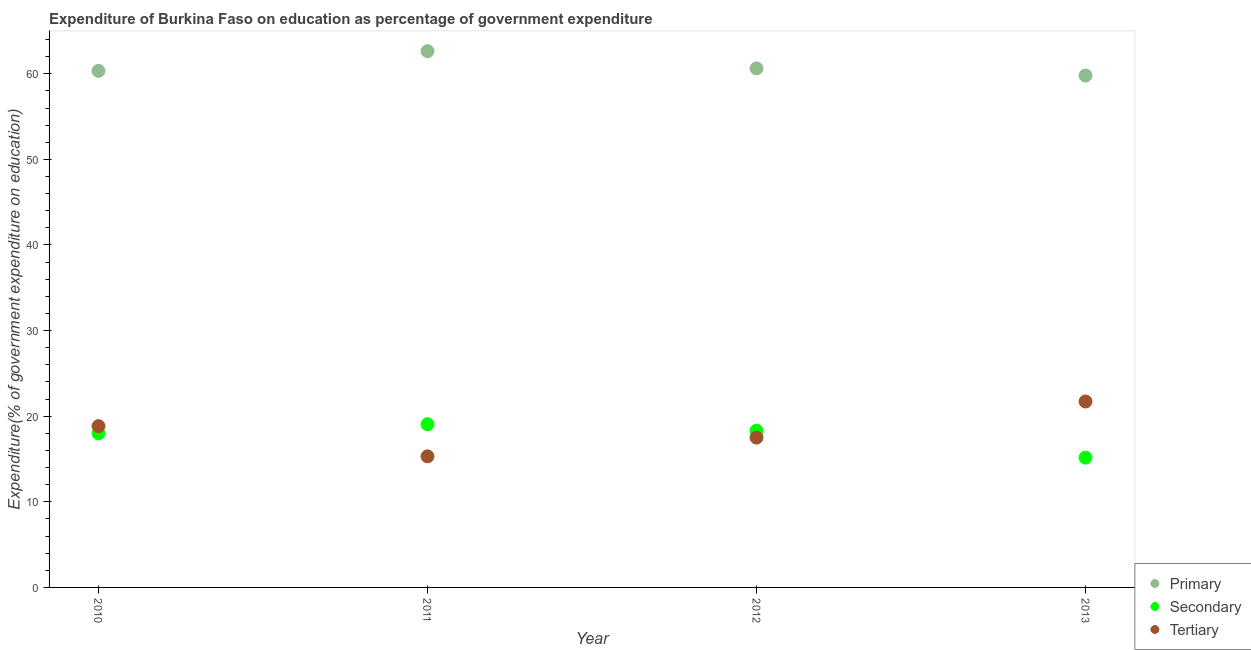Is the number of dotlines equal to the number of legend labels?
Your answer should be compact. Yes. What is the expenditure on secondary education in 2010?
Offer a very short reply. 18. Across all years, what is the maximum expenditure on secondary education?
Offer a very short reply. 19.06. Across all years, what is the minimum expenditure on secondary education?
Your answer should be compact. 15.16. In which year was the expenditure on tertiary education maximum?
Offer a terse response. 2013. In which year was the expenditure on primary education minimum?
Offer a terse response. 2013. What is the total expenditure on tertiary education in the graph?
Give a very brief answer. 73.37. What is the difference between the expenditure on primary education in 2010 and that in 2013?
Offer a terse response. 0.55. What is the difference between the expenditure on tertiary education in 2011 and the expenditure on secondary education in 2013?
Provide a succinct answer. 0.15. What is the average expenditure on secondary education per year?
Provide a succinct answer. 17.63. In the year 2013, what is the difference between the expenditure on primary education and expenditure on secondary education?
Your answer should be very brief. 44.63. In how many years, is the expenditure on secondary education greater than 50 %?
Provide a short and direct response. 0. What is the ratio of the expenditure on secondary education in 2010 to that in 2013?
Your answer should be compact. 1.19. What is the difference between the highest and the second highest expenditure on primary education?
Provide a short and direct response. 2.01. What is the difference between the highest and the lowest expenditure on secondary education?
Make the answer very short. 3.9. Is it the case that in every year, the sum of the expenditure on primary education and expenditure on secondary education is greater than the expenditure on tertiary education?
Make the answer very short. Yes. Does the expenditure on primary education monotonically increase over the years?
Your response must be concise. No. What is the difference between two consecutive major ticks on the Y-axis?
Offer a terse response. 10. Does the graph contain any zero values?
Your answer should be very brief. No. Where does the legend appear in the graph?
Provide a succinct answer. Bottom right. How many legend labels are there?
Keep it short and to the point. 3. What is the title of the graph?
Your response must be concise. Expenditure of Burkina Faso on education as percentage of government expenditure. Does "Male employers" appear as one of the legend labels in the graph?
Provide a succinct answer. No. What is the label or title of the X-axis?
Ensure brevity in your answer.  Year. What is the label or title of the Y-axis?
Keep it short and to the point. Expenditure(% of government expenditure on education). What is the Expenditure(% of government expenditure on education) of Primary in 2010?
Keep it short and to the point. 60.34. What is the Expenditure(% of government expenditure on education) of Secondary in 2010?
Offer a terse response. 18. What is the Expenditure(% of government expenditure on education) in Tertiary in 2010?
Offer a terse response. 18.84. What is the Expenditure(% of government expenditure on education) of Primary in 2011?
Make the answer very short. 62.64. What is the Expenditure(% of government expenditure on education) in Secondary in 2011?
Keep it short and to the point. 19.06. What is the Expenditure(% of government expenditure on education) in Tertiary in 2011?
Provide a succinct answer. 15.31. What is the Expenditure(% of government expenditure on education) of Primary in 2012?
Ensure brevity in your answer.  60.63. What is the Expenditure(% of government expenditure on education) in Secondary in 2012?
Give a very brief answer. 18.31. What is the Expenditure(% of government expenditure on education) of Tertiary in 2012?
Make the answer very short. 17.5. What is the Expenditure(% of government expenditure on education) in Primary in 2013?
Provide a succinct answer. 59.79. What is the Expenditure(% of government expenditure on education) in Secondary in 2013?
Offer a very short reply. 15.16. What is the Expenditure(% of government expenditure on education) of Tertiary in 2013?
Offer a very short reply. 21.72. Across all years, what is the maximum Expenditure(% of government expenditure on education) of Primary?
Make the answer very short. 62.64. Across all years, what is the maximum Expenditure(% of government expenditure on education) in Secondary?
Provide a short and direct response. 19.06. Across all years, what is the maximum Expenditure(% of government expenditure on education) of Tertiary?
Offer a very short reply. 21.72. Across all years, what is the minimum Expenditure(% of government expenditure on education) in Primary?
Provide a short and direct response. 59.79. Across all years, what is the minimum Expenditure(% of government expenditure on education) in Secondary?
Your response must be concise. 15.16. Across all years, what is the minimum Expenditure(% of government expenditure on education) in Tertiary?
Provide a succinct answer. 15.31. What is the total Expenditure(% of government expenditure on education) of Primary in the graph?
Offer a terse response. 243.4. What is the total Expenditure(% of government expenditure on education) in Secondary in the graph?
Offer a terse response. 70.53. What is the total Expenditure(% of government expenditure on education) in Tertiary in the graph?
Provide a succinct answer. 73.37. What is the difference between the Expenditure(% of government expenditure on education) of Primary in 2010 and that in 2011?
Your response must be concise. -2.3. What is the difference between the Expenditure(% of government expenditure on education) in Secondary in 2010 and that in 2011?
Keep it short and to the point. -1.06. What is the difference between the Expenditure(% of government expenditure on education) in Tertiary in 2010 and that in 2011?
Keep it short and to the point. 3.53. What is the difference between the Expenditure(% of government expenditure on education) in Primary in 2010 and that in 2012?
Your response must be concise. -0.29. What is the difference between the Expenditure(% of government expenditure on education) in Secondary in 2010 and that in 2012?
Make the answer very short. -0.3. What is the difference between the Expenditure(% of government expenditure on education) of Tertiary in 2010 and that in 2012?
Give a very brief answer. 1.34. What is the difference between the Expenditure(% of government expenditure on education) in Primary in 2010 and that in 2013?
Make the answer very short. 0.55. What is the difference between the Expenditure(% of government expenditure on education) in Secondary in 2010 and that in 2013?
Provide a short and direct response. 2.84. What is the difference between the Expenditure(% of government expenditure on education) in Tertiary in 2010 and that in 2013?
Offer a very short reply. -2.88. What is the difference between the Expenditure(% of government expenditure on education) in Primary in 2011 and that in 2012?
Ensure brevity in your answer.  2.01. What is the difference between the Expenditure(% of government expenditure on education) in Secondary in 2011 and that in 2012?
Your response must be concise. 0.76. What is the difference between the Expenditure(% of government expenditure on education) of Tertiary in 2011 and that in 2012?
Your response must be concise. -2.19. What is the difference between the Expenditure(% of government expenditure on education) in Primary in 2011 and that in 2013?
Provide a succinct answer. 2.85. What is the difference between the Expenditure(% of government expenditure on education) of Secondary in 2011 and that in 2013?
Ensure brevity in your answer.  3.9. What is the difference between the Expenditure(% of government expenditure on education) of Tertiary in 2011 and that in 2013?
Ensure brevity in your answer.  -6.41. What is the difference between the Expenditure(% of government expenditure on education) of Primary in 2012 and that in 2013?
Your answer should be compact. 0.84. What is the difference between the Expenditure(% of government expenditure on education) of Secondary in 2012 and that in 2013?
Your response must be concise. 3.14. What is the difference between the Expenditure(% of government expenditure on education) in Tertiary in 2012 and that in 2013?
Provide a succinct answer. -4.22. What is the difference between the Expenditure(% of government expenditure on education) in Primary in 2010 and the Expenditure(% of government expenditure on education) in Secondary in 2011?
Offer a terse response. 41.28. What is the difference between the Expenditure(% of government expenditure on education) of Primary in 2010 and the Expenditure(% of government expenditure on education) of Tertiary in 2011?
Keep it short and to the point. 45.03. What is the difference between the Expenditure(% of government expenditure on education) of Secondary in 2010 and the Expenditure(% of government expenditure on education) of Tertiary in 2011?
Make the answer very short. 2.69. What is the difference between the Expenditure(% of government expenditure on education) in Primary in 2010 and the Expenditure(% of government expenditure on education) in Secondary in 2012?
Offer a very short reply. 42.04. What is the difference between the Expenditure(% of government expenditure on education) in Primary in 2010 and the Expenditure(% of government expenditure on education) in Tertiary in 2012?
Provide a short and direct response. 42.84. What is the difference between the Expenditure(% of government expenditure on education) of Secondary in 2010 and the Expenditure(% of government expenditure on education) of Tertiary in 2012?
Give a very brief answer. 0.5. What is the difference between the Expenditure(% of government expenditure on education) in Primary in 2010 and the Expenditure(% of government expenditure on education) in Secondary in 2013?
Your answer should be very brief. 45.18. What is the difference between the Expenditure(% of government expenditure on education) of Primary in 2010 and the Expenditure(% of government expenditure on education) of Tertiary in 2013?
Your response must be concise. 38.62. What is the difference between the Expenditure(% of government expenditure on education) in Secondary in 2010 and the Expenditure(% of government expenditure on education) in Tertiary in 2013?
Provide a short and direct response. -3.72. What is the difference between the Expenditure(% of government expenditure on education) of Primary in 2011 and the Expenditure(% of government expenditure on education) of Secondary in 2012?
Give a very brief answer. 44.34. What is the difference between the Expenditure(% of government expenditure on education) of Primary in 2011 and the Expenditure(% of government expenditure on education) of Tertiary in 2012?
Make the answer very short. 45.14. What is the difference between the Expenditure(% of government expenditure on education) of Secondary in 2011 and the Expenditure(% of government expenditure on education) of Tertiary in 2012?
Your answer should be compact. 1.56. What is the difference between the Expenditure(% of government expenditure on education) of Primary in 2011 and the Expenditure(% of government expenditure on education) of Secondary in 2013?
Provide a short and direct response. 47.48. What is the difference between the Expenditure(% of government expenditure on education) in Primary in 2011 and the Expenditure(% of government expenditure on education) in Tertiary in 2013?
Provide a short and direct response. 40.92. What is the difference between the Expenditure(% of government expenditure on education) of Secondary in 2011 and the Expenditure(% of government expenditure on education) of Tertiary in 2013?
Give a very brief answer. -2.65. What is the difference between the Expenditure(% of government expenditure on education) in Primary in 2012 and the Expenditure(% of government expenditure on education) in Secondary in 2013?
Provide a short and direct response. 45.46. What is the difference between the Expenditure(% of government expenditure on education) in Primary in 2012 and the Expenditure(% of government expenditure on education) in Tertiary in 2013?
Give a very brief answer. 38.91. What is the difference between the Expenditure(% of government expenditure on education) in Secondary in 2012 and the Expenditure(% of government expenditure on education) in Tertiary in 2013?
Provide a short and direct response. -3.41. What is the average Expenditure(% of government expenditure on education) of Primary per year?
Offer a terse response. 60.85. What is the average Expenditure(% of government expenditure on education) of Secondary per year?
Give a very brief answer. 17.63. What is the average Expenditure(% of government expenditure on education) in Tertiary per year?
Your answer should be very brief. 18.34. In the year 2010, what is the difference between the Expenditure(% of government expenditure on education) in Primary and Expenditure(% of government expenditure on education) in Secondary?
Your answer should be very brief. 42.34. In the year 2010, what is the difference between the Expenditure(% of government expenditure on education) in Primary and Expenditure(% of government expenditure on education) in Tertiary?
Offer a terse response. 41.5. In the year 2010, what is the difference between the Expenditure(% of government expenditure on education) of Secondary and Expenditure(% of government expenditure on education) of Tertiary?
Provide a short and direct response. -0.84. In the year 2011, what is the difference between the Expenditure(% of government expenditure on education) in Primary and Expenditure(% of government expenditure on education) in Secondary?
Your answer should be very brief. 43.58. In the year 2011, what is the difference between the Expenditure(% of government expenditure on education) of Primary and Expenditure(% of government expenditure on education) of Tertiary?
Make the answer very short. 47.33. In the year 2011, what is the difference between the Expenditure(% of government expenditure on education) in Secondary and Expenditure(% of government expenditure on education) in Tertiary?
Provide a succinct answer. 3.75. In the year 2012, what is the difference between the Expenditure(% of government expenditure on education) in Primary and Expenditure(% of government expenditure on education) in Secondary?
Your response must be concise. 42.32. In the year 2012, what is the difference between the Expenditure(% of government expenditure on education) in Primary and Expenditure(% of government expenditure on education) in Tertiary?
Give a very brief answer. 43.13. In the year 2012, what is the difference between the Expenditure(% of government expenditure on education) of Secondary and Expenditure(% of government expenditure on education) of Tertiary?
Your answer should be very brief. 0.8. In the year 2013, what is the difference between the Expenditure(% of government expenditure on education) of Primary and Expenditure(% of government expenditure on education) of Secondary?
Ensure brevity in your answer.  44.63. In the year 2013, what is the difference between the Expenditure(% of government expenditure on education) of Primary and Expenditure(% of government expenditure on education) of Tertiary?
Offer a terse response. 38.07. In the year 2013, what is the difference between the Expenditure(% of government expenditure on education) of Secondary and Expenditure(% of government expenditure on education) of Tertiary?
Your response must be concise. -6.56. What is the ratio of the Expenditure(% of government expenditure on education) in Primary in 2010 to that in 2011?
Ensure brevity in your answer.  0.96. What is the ratio of the Expenditure(% of government expenditure on education) of Secondary in 2010 to that in 2011?
Provide a succinct answer. 0.94. What is the ratio of the Expenditure(% of government expenditure on education) in Tertiary in 2010 to that in 2011?
Your response must be concise. 1.23. What is the ratio of the Expenditure(% of government expenditure on education) of Primary in 2010 to that in 2012?
Provide a succinct answer. 1. What is the ratio of the Expenditure(% of government expenditure on education) of Secondary in 2010 to that in 2012?
Ensure brevity in your answer.  0.98. What is the ratio of the Expenditure(% of government expenditure on education) of Tertiary in 2010 to that in 2012?
Give a very brief answer. 1.08. What is the ratio of the Expenditure(% of government expenditure on education) of Primary in 2010 to that in 2013?
Your answer should be compact. 1.01. What is the ratio of the Expenditure(% of government expenditure on education) in Secondary in 2010 to that in 2013?
Make the answer very short. 1.19. What is the ratio of the Expenditure(% of government expenditure on education) in Tertiary in 2010 to that in 2013?
Offer a terse response. 0.87. What is the ratio of the Expenditure(% of government expenditure on education) in Primary in 2011 to that in 2012?
Keep it short and to the point. 1.03. What is the ratio of the Expenditure(% of government expenditure on education) of Secondary in 2011 to that in 2012?
Your answer should be very brief. 1.04. What is the ratio of the Expenditure(% of government expenditure on education) of Tertiary in 2011 to that in 2012?
Your answer should be very brief. 0.87. What is the ratio of the Expenditure(% of government expenditure on education) in Primary in 2011 to that in 2013?
Give a very brief answer. 1.05. What is the ratio of the Expenditure(% of government expenditure on education) in Secondary in 2011 to that in 2013?
Provide a succinct answer. 1.26. What is the ratio of the Expenditure(% of government expenditure on education) in Tertiary in 2011 to that in 2013?
Your answer should be compact. 0.7. What is the ratio of the Expenditure(% of government expenditure on education) in Secondary in 2012 to that in 2013?
Your answer should be very brief. 1.21. What is the ratio of the Expenditure(% of government expenditure on education) of Tertiary in 2012 to that in 2013?
Your answer should be compact. 0.81. What is the difference between the highest and the second highest Expenditure(% of government expenditure on education) of Primary?
Provide a short and direct response. 2.01. What is the difference between the highest and the second highest Expenditure(% of government expenditure on education) of Secondary?
Make the answer very short. 0.76. What is the difference between the highest and the second highest Expenditure(% of government expenditure on education) in Tertiary?
Offer a terse response. 2.88. What is the difference between the highest and the lowest Expenditure(% of government expenditure on education) of Primary?
Provide a succinct answer. 2.85. What is the difference between the highest and the lowest Expenditure(% of government expenditure on education) in Secondary?
Offer a very short reply. 3.9. What is the difference between the highest and the lowest Expenditure(% of government expenditure on education) in Tertiary?
Provide a short and direct response. 6.41. 